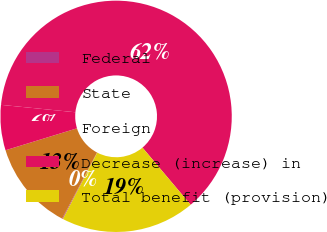<chart> <loc_0><loc_0><loc_500><loc_500><pie_chart><fcel>Federal<fcel>State<fcel>Foreign<fcel>Decrease (increase) in<fcel>Total benefit (provision)<nl><fcel>0.11%<fcel>12.54%<fcel>6.32%<fcel>62.28%<fcel>18.76%<nl></chart> 